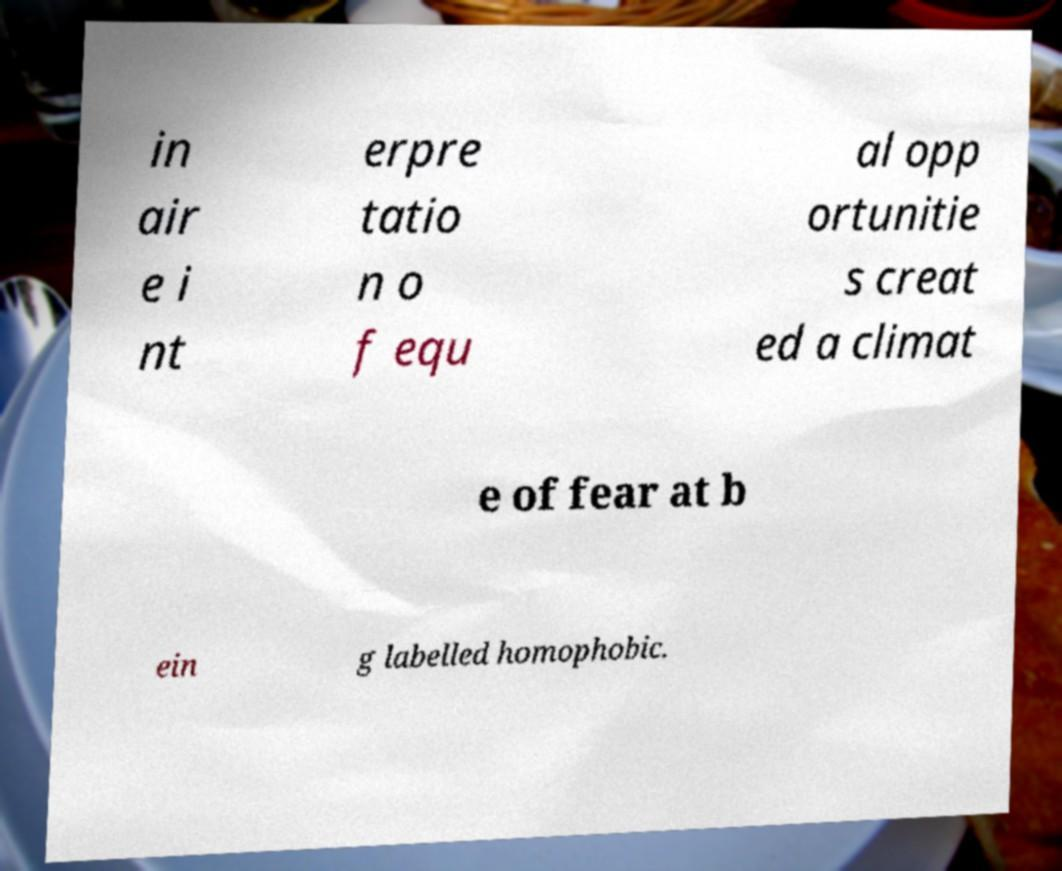Could you assist in decoding the text presented in this image and type it out clearly? in air e i nt erpre tatio n o f equ al opp ortunitie s creat ed a climat e of fear at b ein g labelled homophobic. 